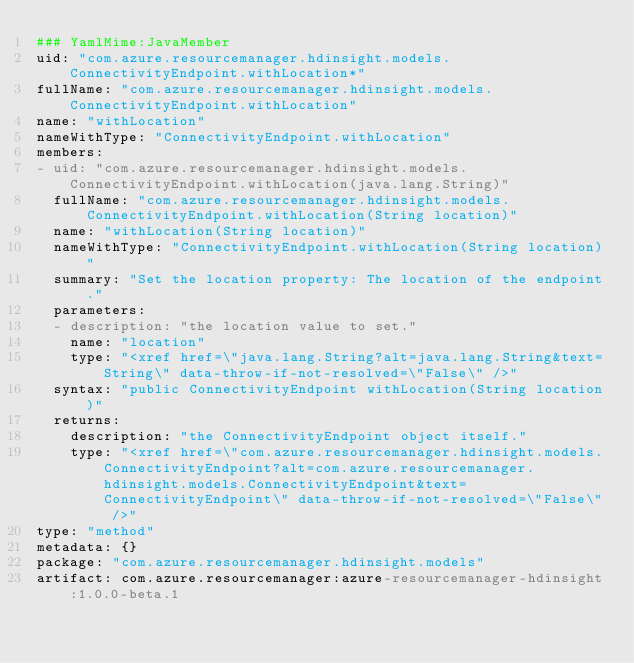<code> <loc_0><loc_0><loc_500><loc_500><_YAML_>### YamlMime:JavaMember
uid: "com.azure.resourcemanager.hdinsight.models.ConnectivityEndpoint.withLocation*"
fullName: "com.azure.resourcemanager.hdinsight.models.ConnectivityEndpoint.withLocation"
name: "withLocation"
nameWithType: "ConnectivityEndpoint.withLocation"
members:
- uid: "com.azure.resourcemanager.hdinsight.models.ConnectivityEndpoint.withLocation(java.lang.String)"
  fullName: "com.azure.resourcemanager.hdinsight.models.ConnectivityEndpoint.withLocation(String location)"
  name: "withLocation(String location)"
  nameWithType: "ConnectivityEndpoint.withLocation(String location)"
  summary: "Set the location property: The location of the endpoint."
  parameters:
  - description: "the location value to set."
    name: "location"
    type: "<xref href=\"java.lang.String?alt=java.lang.String&text=String\" data-throw-if-not-resolved=\"False\" />"
  syntax: "public ConnectivityEndpoint withLocation(String location)"
  returns:
    description: "the ConnectivityEndpoint object itself."
    type: "<xref href=\"com.azure.resourcemanager.hdinsight.models.ConnectivityEndpoint?alt=com.azure.resourcemanager.hdinsight.models.ConnectivityEndpoint&text=ConnectivityEndpoint\" data-throw-if-not-resolved=\"False\" />"
type: "method"
metadata: {}
package: "com.azure.resourcemanager.hdinsight.models"
artifact: com.azure.resourcemanager:azure-resourcemanager-hdinsight:1.0.0-beta.1
</code> 